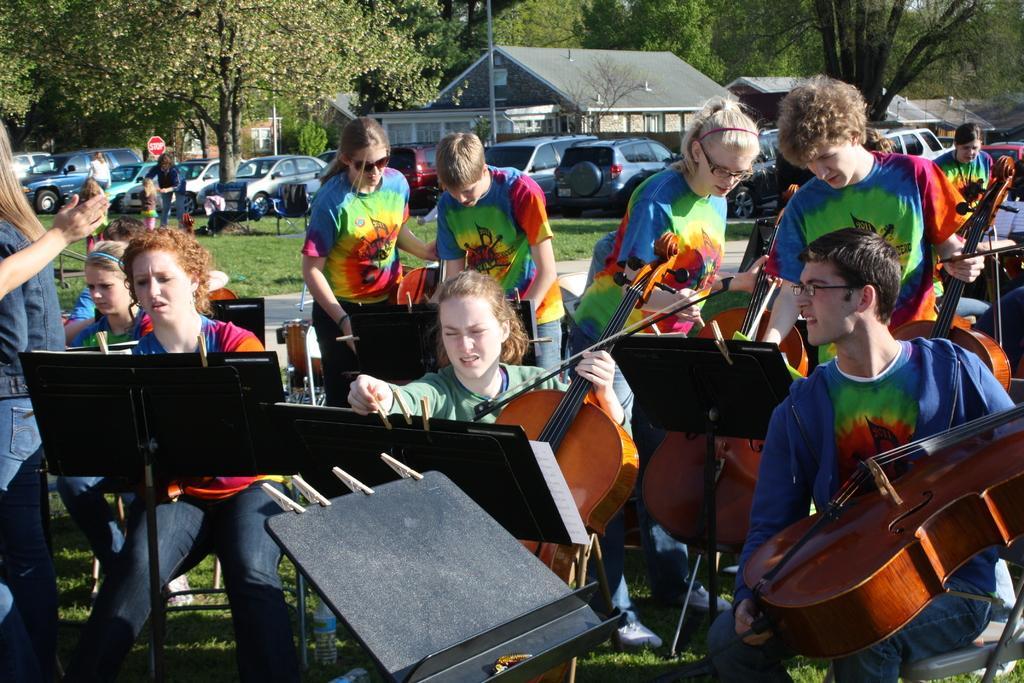Can you describe this image briefly? Bottom of the image few people are sitting and standing and holding some musical instruments. Behind them there is a grass and there are some vehicles. Top of the image there are few buildings and trees. 